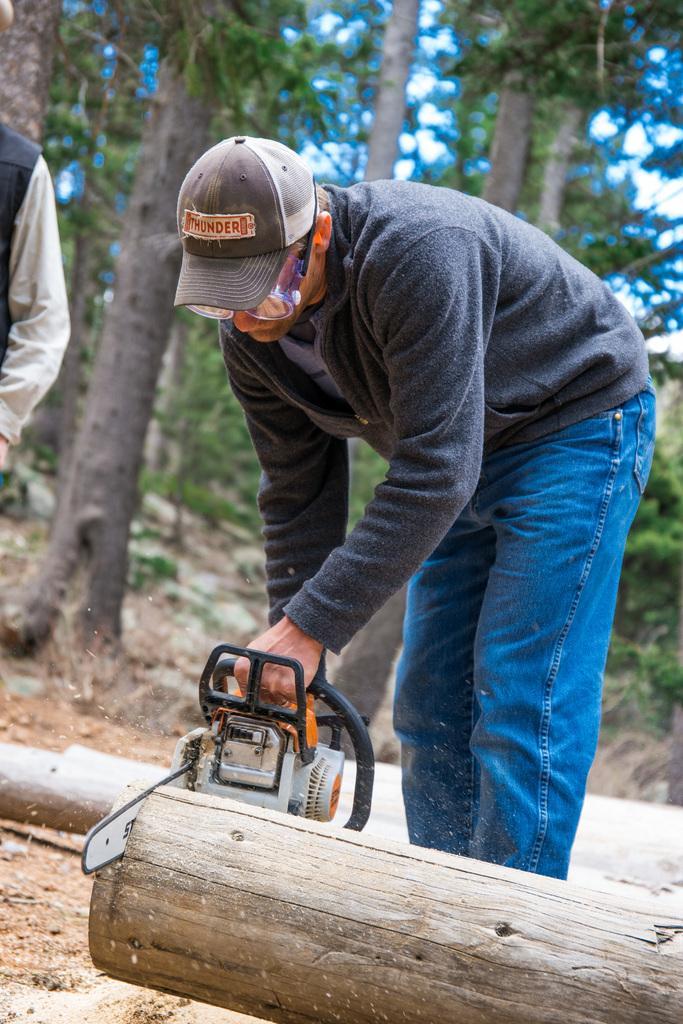Describe this image in one or two sentences. In this image I can see a person is cutting wood by using a wood cutter. I can see another person standing on the left hand side of the image. I can see trees behind them with a blurred background. 